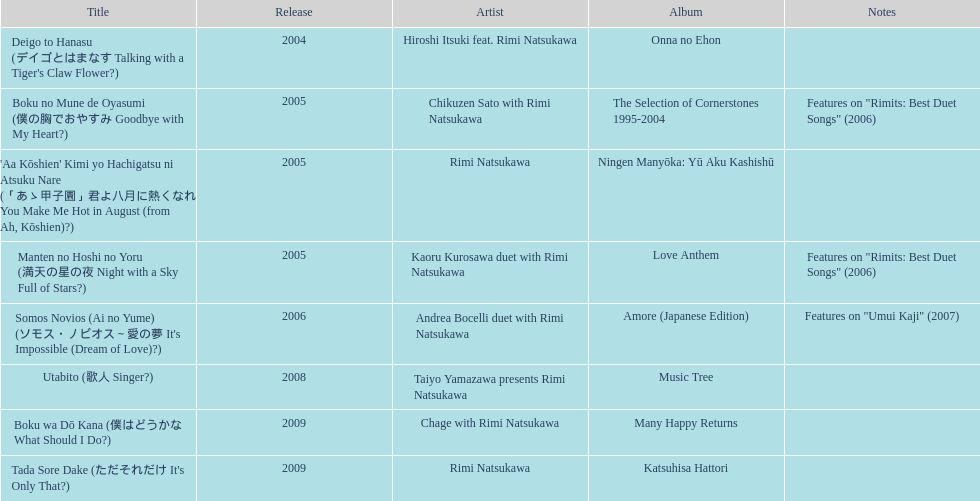What is the last title released? 2009. 